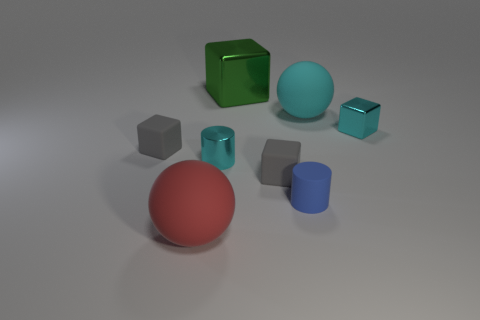Imagine that these objects are part of an art installation. What theme or message could they be trying to convey? Interpreted as an art installation, the arrangement of these objects could symbolize the diversity and unity present in the natural world. Each shape and material might represent the unique entities that coexist within a harmonious system, suggesting a message about the value of variety and balance in our ecosystem or social fabric. 